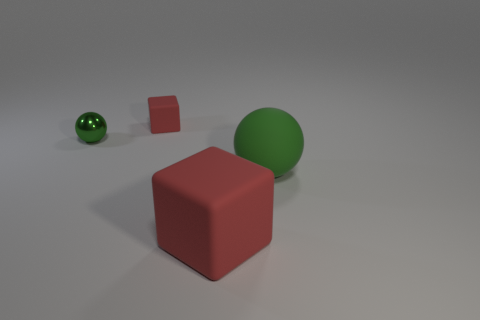Add 4 green objects. How many objects exist? 8 Subtract 0 yellow spheres. How many objects are left? 4 Subtract all big red rubber cubes. Subtract all matte objects. How many objects are left? 0 Add 4 red rubber things. How many red rubber things are left? 6 Add 1 tiny brown shiny cubes. How many tiny brown shiny cubes exist? 1 